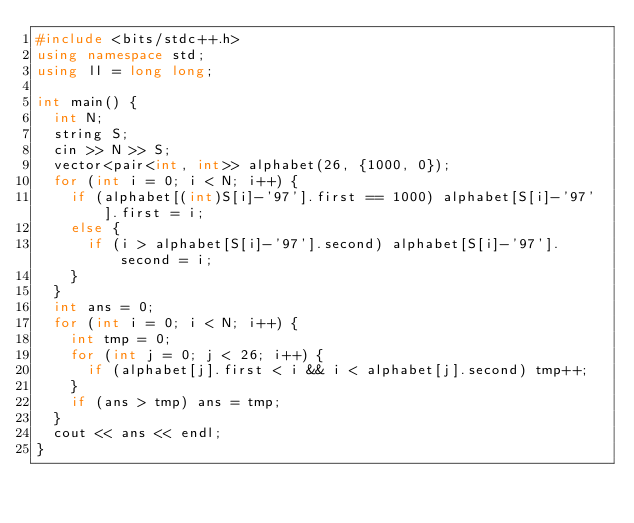Convert code to text. <code><loc_0><loc_0><loc_500><loc_500><_C++_>#include <bits/stdc++.h>
using namespace std;
using ll = long long;

int main() {
  int N;
  string S;
  cin >> N >> S;
  vector<pair<int, int>> alphabet(26, {1000, 0});
  for (int i = 0; i < N; i++) {
    if (alphabet[(int)S[i]-'97'].first == 1000) alphabet[S[i]-'97'].first = i;
    else {
      if (i > alphabet[S[i]-'97'].second) alphabet[S[i]-'97'].second = i;
    }
  }
  int ans = 0;
  for (int i = 0; i < N; i++) {
    int tmp = 0;
    for (int j = 0; j < 26; i++) {
      if (alphabet[j].first < i && i < alphabet[j].second) tmp++;
    }
    if (ans > tmp) ans = tmp;
  }
  cout << ans << endl;
}
</code> 